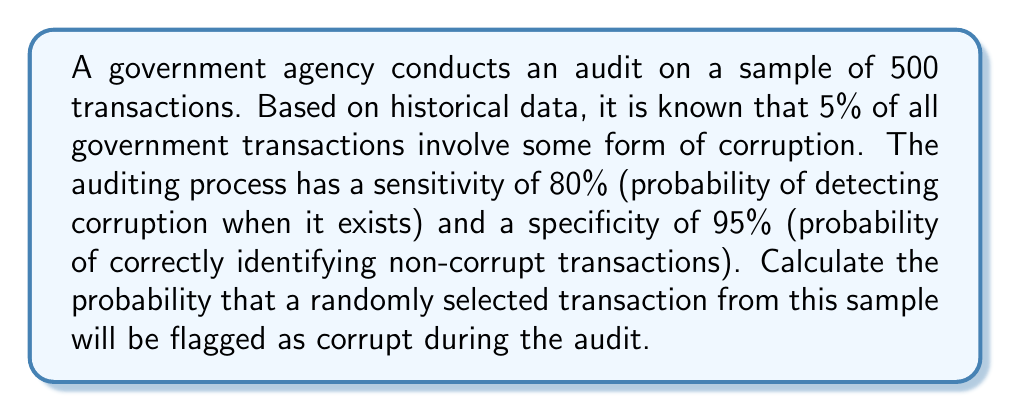What is the answer to this math problem? Let's approach this step-by-step:

1) First, we need to define our events:
   A: Transaction is actually corrupt
   B: Transaction is flagged as corrupt

2) We're given the following probabilities:
   $P(A) = 0.05$ (5% of transactions are corrupt)
   $P(B|A) = 0.80$ (80% sensitivity)
   $P(\neg B|\neg A) = 0.95$ (95% specificity)

3) We can calculate $P(\neg A)$ and $P(B|\neg A)$:
   $P(\neg A) = 1 - P(A) = 0.95$
   $P(B|\neg A) = 1 - P(\neg B|\neg A) = 0.05$

4) We can use the law of total probability to calculate $P(B)$:

   $$P(B) = P(B|A)P(A) + P(B|\neg A)P(\neg A)$$

5) Substituting the values:

   $$P(B) = (0.80)(0.05) + (0.05)(0.95)$$

6) Calculating:

   $$P(B) = 0.04 + 0.0475 = 0.0875$$

Therefore, the probability that a randomly selected transaction will be flagged as corrupt is 0.0875 or 8.75%.
Answer: 0.0875 